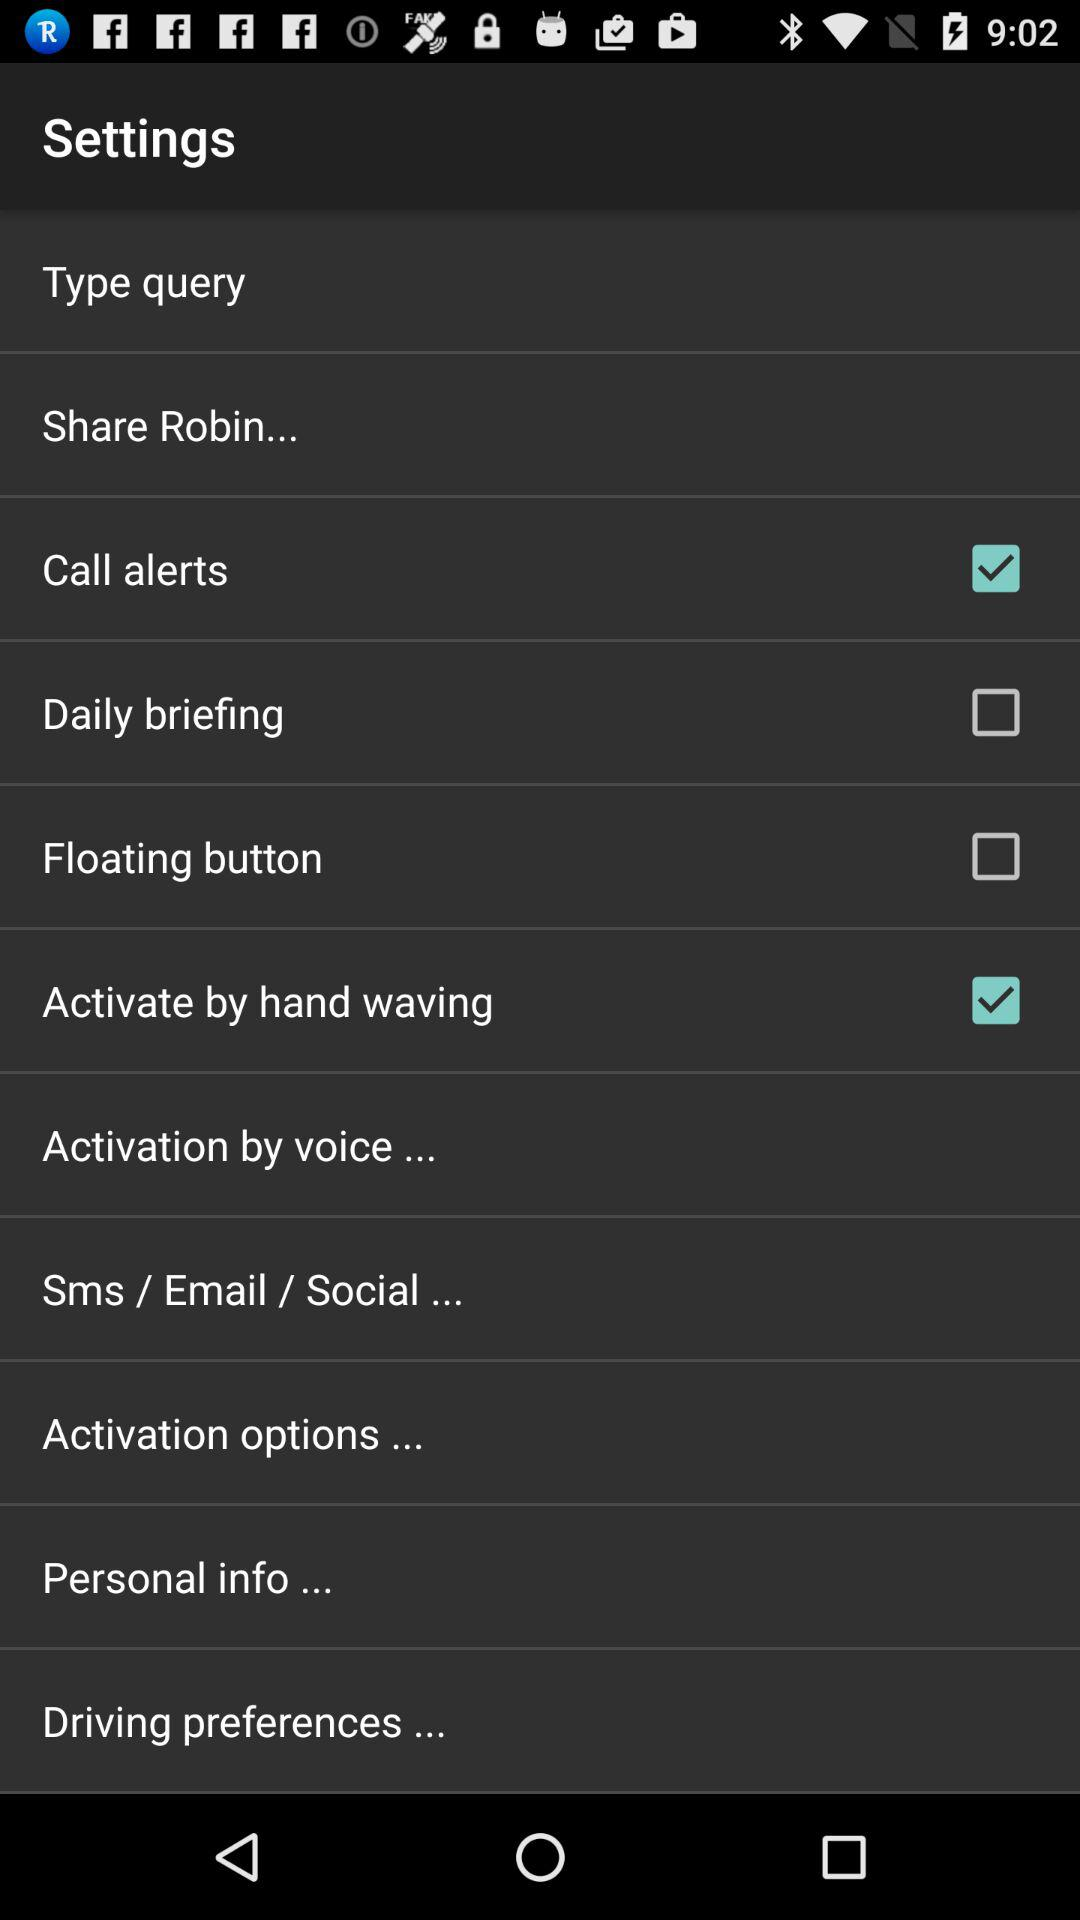What's the status of "Call alerts"? The status is on. 